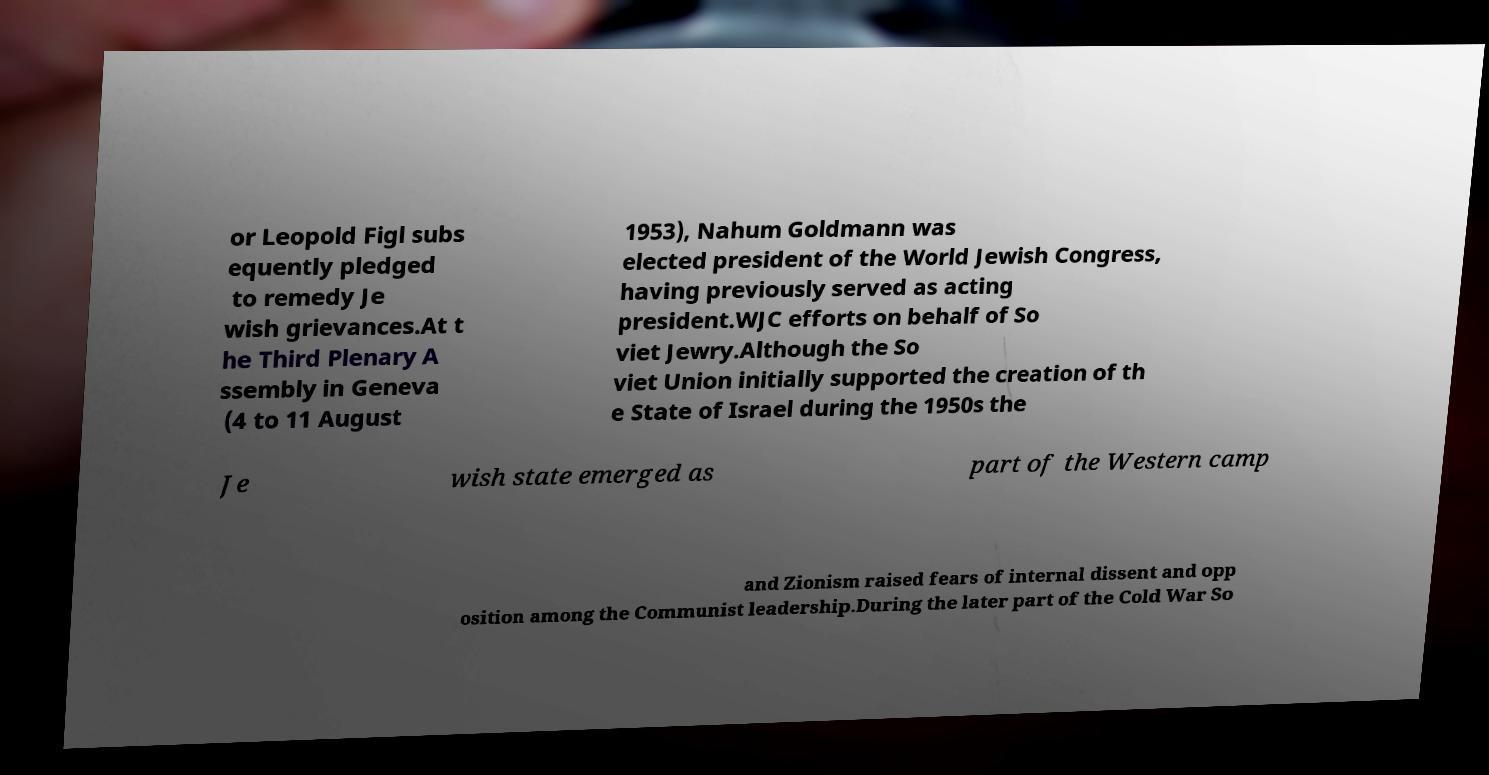Could you assist in decoding the text presented in this image and type it out clearly? or Leopold Figl subs equently pledged to remedy Je wish grievances.At t he Third Plenary A ssembly in Geneva (4 to 11 August 1953), Nahum Goldmann was elected president of the World Jewish Congress, having previously served as acting president.WJC efforts on behalf of So viet Jewry.Although the So viet Union initially supported the creation of th e State of Israel during the 1950s the Je wish state emerged as part of the Western camp and Zionism raised fears of internal dissent and opp osition among the Communist leadership.During the later part of the Cold War So 